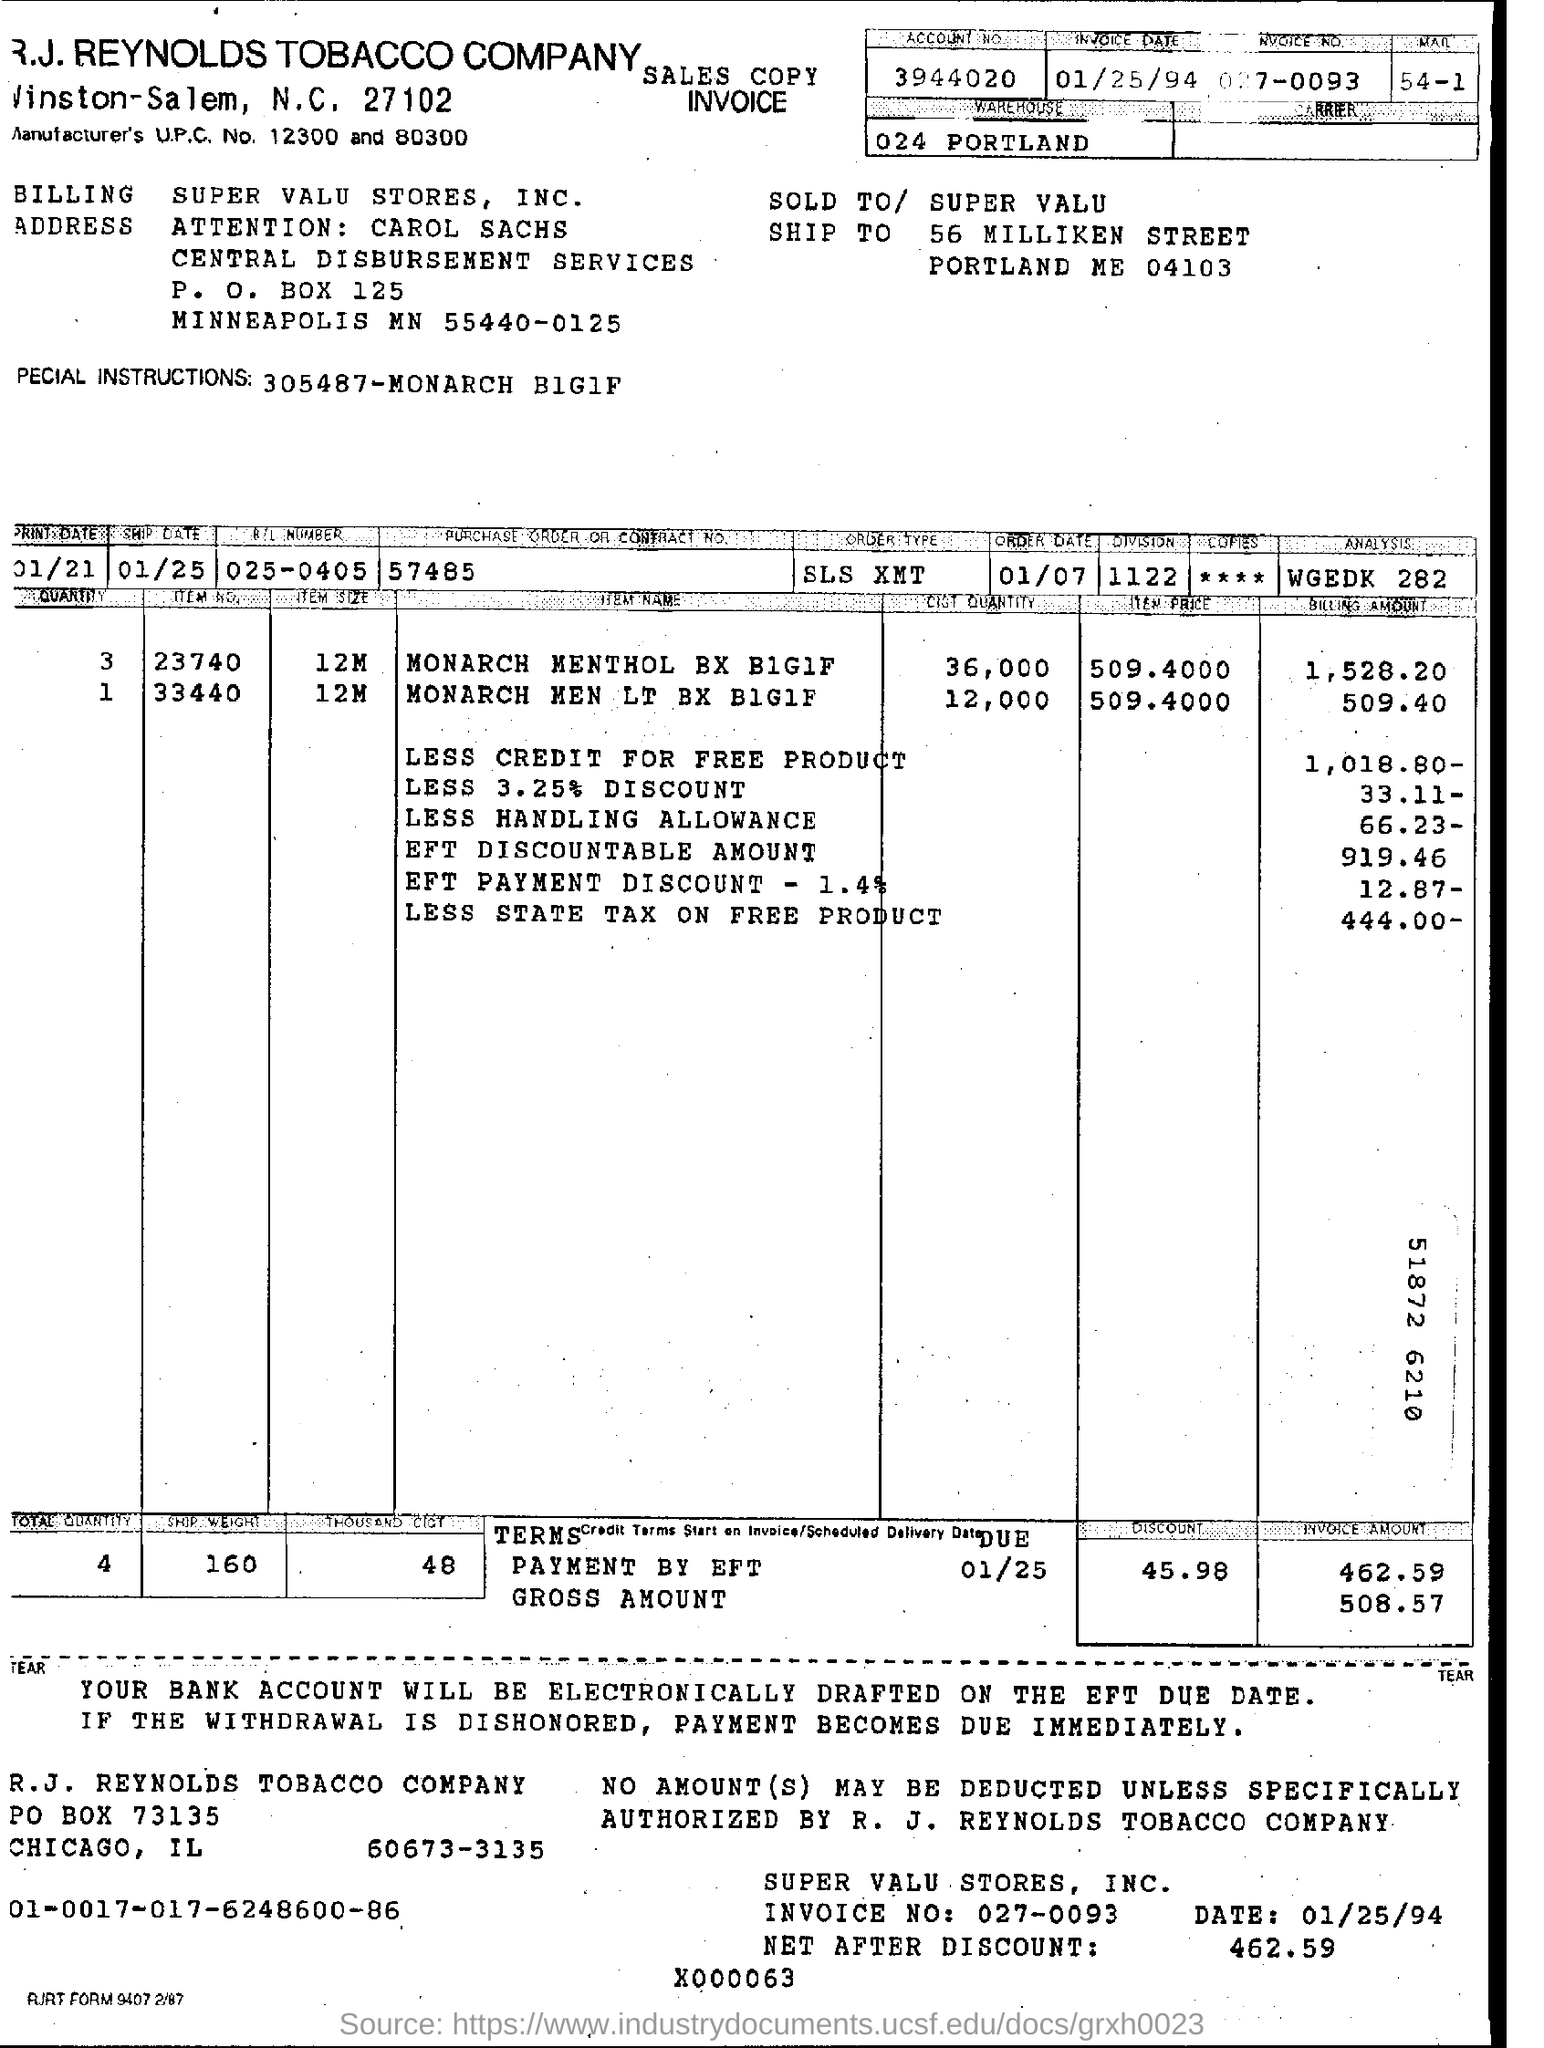What is the purchase order or contract no?
Ensure brevity in your answer.  57485. What is the invoice date?
Provide a short and direct response. 01/25/94. What is the invoice number?
Give a very brief answer. 027-0093. What is the P.O box number of Billing address?
Provide a short and direct response. 125. What is item size of item number 23740?
Provide a succinct answer. 12M. 